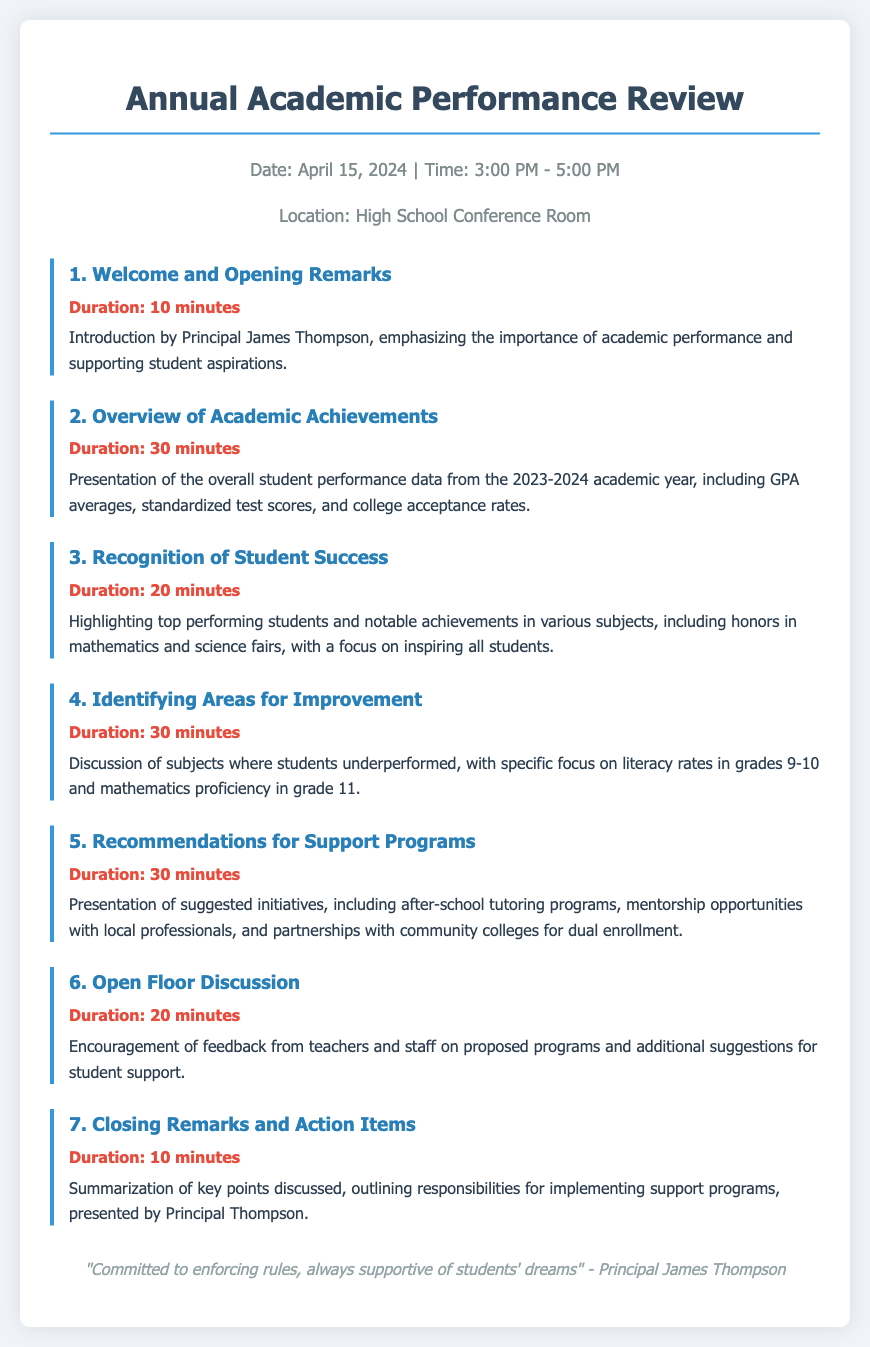What is the date of the review? The date of the review is mentioned as April 15, 2024.
Answer: April 15, 2024 Who introduced the meeting? The introduction is done by Principal James Thompson.
Answer: Principal James Thompson How long is the Overview of Academic Achievements presentation? The duration of the presentation on academic achievements is specified in the agenda.
Answer: 30 minutes Which grades are specifically mentioned for identifying areas for improvement? The grades mentioned for areas of improvement are 9-10 for literacy rates and 11 for mathematics proficiency.
Answer: Grades 9-10 and 11 What are two recommended support programs mentioned? Suggested initiatives for support are outlined in the document, including tutoring programs and mentorship opportunities.
Answer: Tutoring programs and mentorship opportunities What does the footer quote emphasize? The footer includes a quote from Principal Thompson that reflects his commitment to rules and student support.
Answer: Commitment to enforcing rules, support for student dreams How many total agenda items are listed? The agenda contains multiple items that are counted to provide an overall number.
Answer: 7 